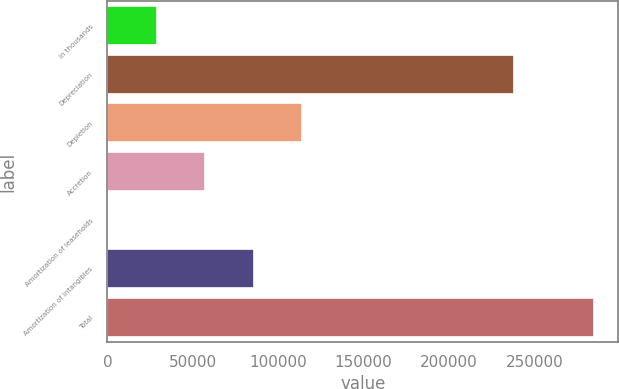Convert chart. <chart><loc_0><loc_0><loc_500><loc_500><bar_chart><fcel>in thousands<fcel>Depreciation<fcel>Depletion<fcel>Accretion<fcel>Amortization of leaseholds<fcel>Amortization of intangibles<fcel>Total<nl><fcel>28734.3<fcel>238237<fcel>114136<fcel>57201.6<fcel>267<fcel>85668.9<fcel>284940<nl></chart> 